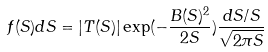Convert formula to latex. <formula><loc_0><loc_0><loc_500><loc_500>f ( S ) d S = | T ( S ) | \exp ( - \frac { B ( S ) ^ { 2 } } { 2 S } ) \frac { d S / S } { \sqrt { 2 \pi S } }</formula> 